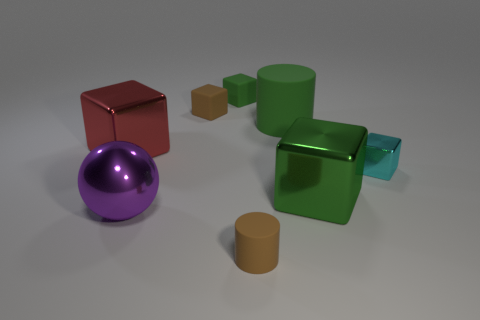Subtract all blue cylinders. How many green cubes are left? 2 Subtract all tiny green rubber cubes. How many cubes are left? 4 Add 1 big yellow metal balls. How many objects exist? 9 Subtract all red cubes. How many cubes are left? 4 Subtract 1 blocks. How many blocks are left? 4 Subtract all gray cubes. Subtract all green cylinders. How many cubes are left? 5 Add 8 large green shiny cubes. How many large green shiny cubes exist? 9 Subtract 0 cyan balls. How many objects are left? 8 Subtract all cubes. How many objects are left? 3 Subtract all red blocks. Subtract all rubber objects. How many objects are left? 3 